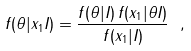Convert formula to latex. <formula><loc_0><loc_0><loc_500><loc_500>f ( \theta | x _ { 1 } I ) = \frac { f ( \theta | I ) \, f ( x _ { 1 } | \theta I ) } { f ( x _ { 1 } | I ) } \ ,</formula> 